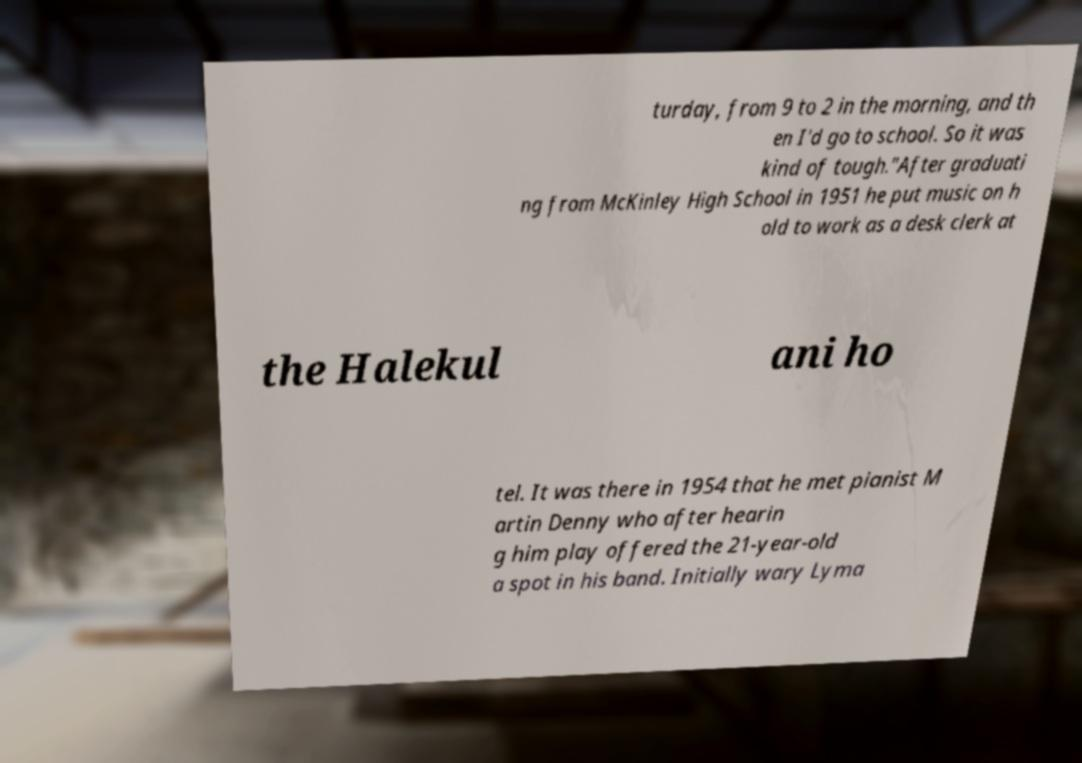Could you extract and type out the text from this image? turday, from 9 to 2 in the morning, and th en I'd go to school. So it was kind of tough."After graduati ng from McKinley High School in 1951 he put music on h old to work as a desk clerk at the Halekul ani ho tel. It was there in 1954 that he met pianist M artin Denny who after hearin g him play offered the 21-year-old a spot in his band. Initially wary Lyma 